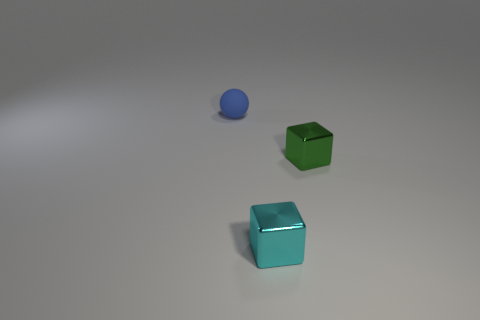Add 2 tiny rubber balls. How many objects exist? 5 Subtract all balls. How many objects are left? 2 Add 1 small balls. How many small balls exist? 2 Subtract 0 red cylinders. How many objects are left? 3 Subtract all tiny gray blocks. Subtract all small blue rubber things. How many objects are left? 2 Add 1 small cyan objects. How many small cyan objects are left? 2 